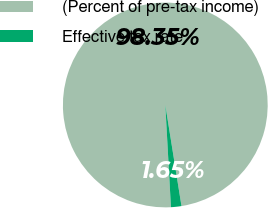Convert chart. <chart><loc_0><loc_0><loc_500><loc_500><pie_chart><fcel>(Percent of pre-tax income)<fcel>Effective tax rate<nl><fcel>98.35%<fcel>1.65%<nl></chart> 